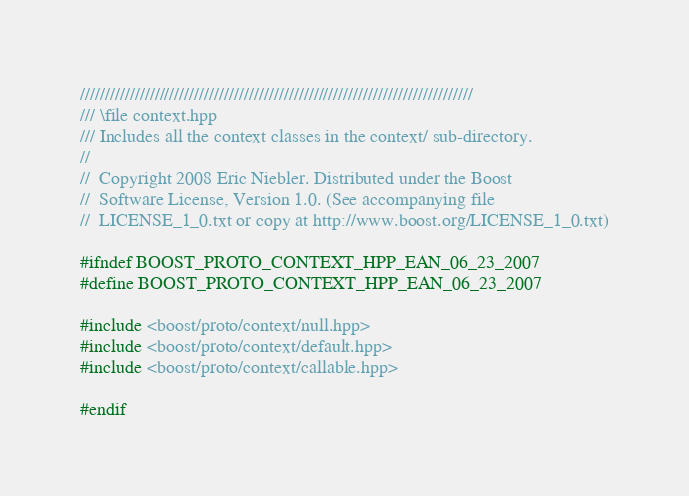Convert code to text. <code><loc_0><loc_0><loc_500><loc_500><_C++_>///////////////////////////////////////////////////////////////////////////////
/// \file context.hpp
/// Includes all the context classes in the context/ sub-directory.
//
//  Copyright 2008 Eric Niebler. Distributed under the Boost
//  Software License, Version 1.0. (See accompanying file
//  LICENSE_1_0.txt or copy at http://www.boost.org/LICENSE_1_0.txt)

#ifndef BOOST_PROTO_CONTEXT_HPP_EAN_06_23_2007
#define BOOST_PROTO_CONTEXT_HPP_EAN_06_23_2007

#include <boost/proto/context/null.hpp>
#include <boost/proto/context/default.hpp>
#include <boost/proto/context/callable.hpp>

#endif
</code> 